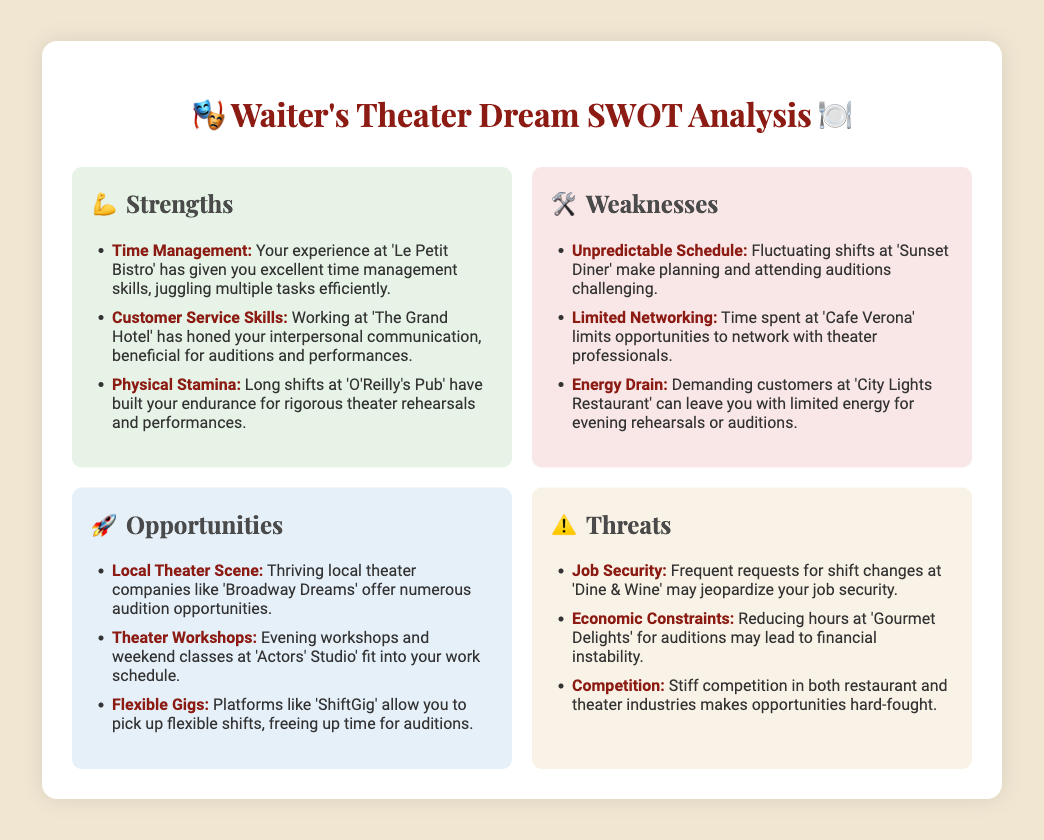what are the three strengths listed? The strengths section contains three points: Time Management, Customer Service Skills, and Physical Stamina.
Answer: Time Management, Customer Service Skills, Physical Stamina what is an opportunity related to theater workshops? In the opportunities section, it mentions evening workshops and weekend classes at 'Actors' Studio' that fit into the work schedule.
Answer: Evening workshops and weekend classes at 'Actors' Studio' what is one of the threats related to job security? The threats section highlights frequent requests for shift changes at 'Dine & Wine', which may jeopardize job security.
Answer: Frequent requests for shift changes at 'Dine & Wine' how many weaknesses are identified in total? The weaknesses section lists three weaknesses: Unpredictable Schedule, Limited Networking, and Energy Drain.
Answer: Three what type of gigs can provide flexibility for auditions? The opportunities section mentions platforms like 'ShiftGig' that allow for flexible shifts.
Answer: Flexible shifts which restaurant is associated with energy drain? The weaknesses section specifies demanding customers at 'City Lights Restaurant' as a cause of energy drain.
Answer: City Lights Restaurant 